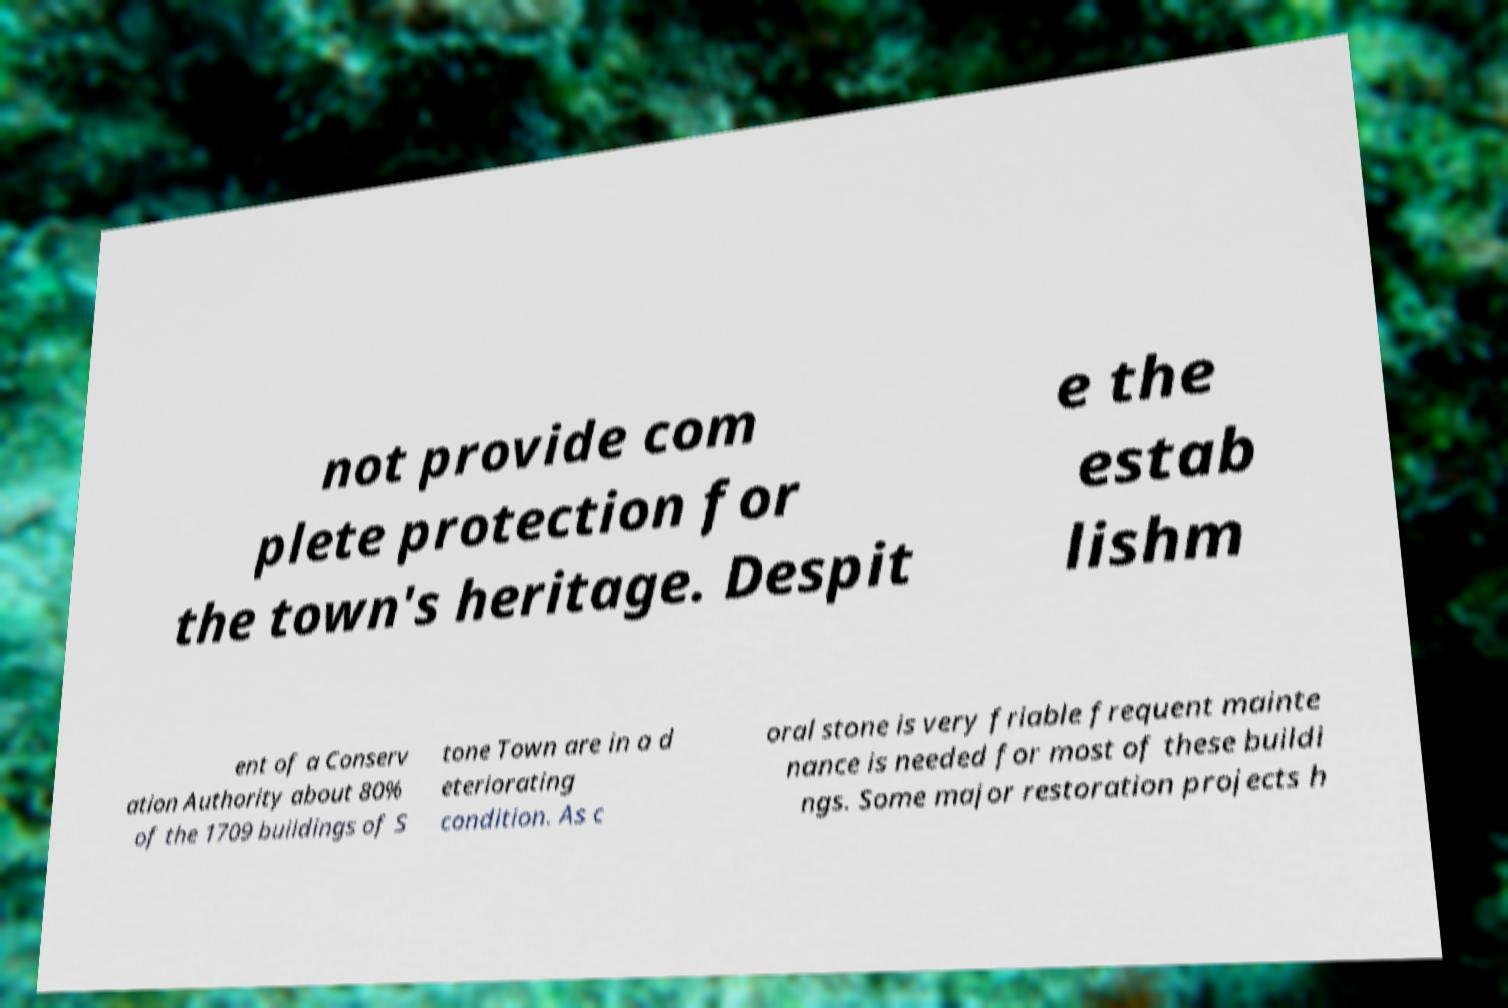Please identify and transcribe the text found in this image. not provide com plete protection for the town's heritage. Despit e the estab lishm ent of a Conserv ation Authority about 80% of the 1709 buildings of S tone Town are in a d eteriorating condition. As c oral stone is very friable frequent mainte nance is needed for most of these buildi ngs. Some major restoration projects h 